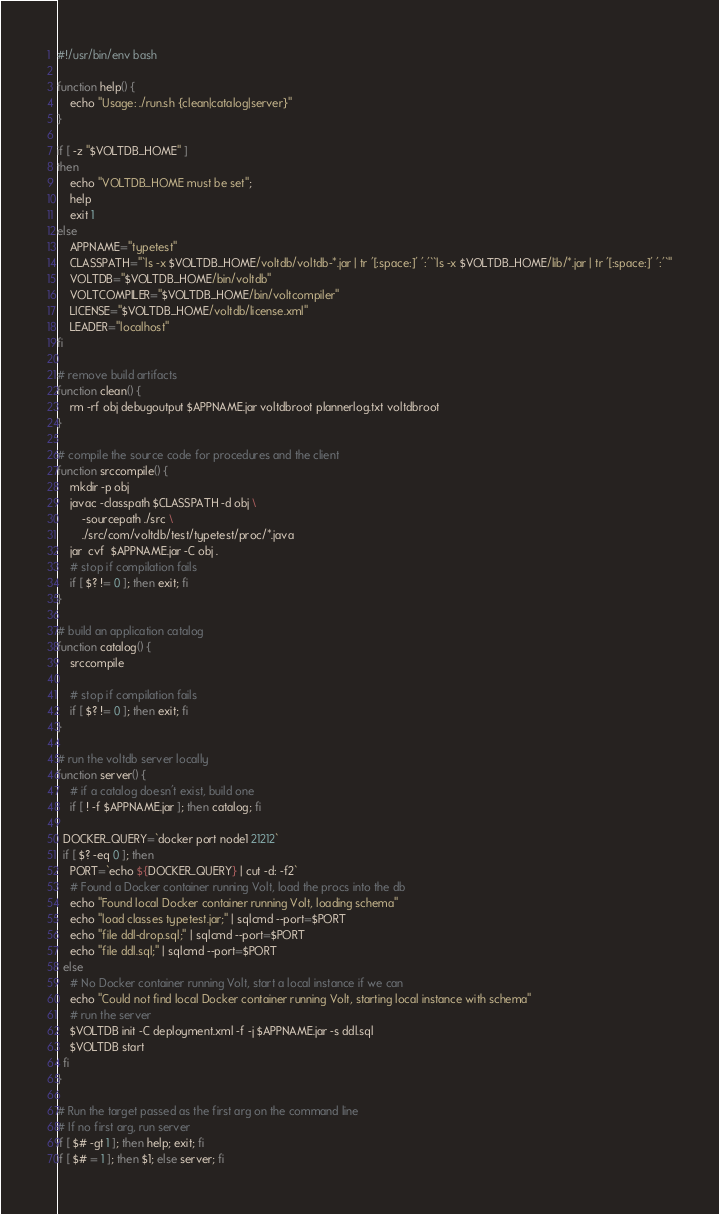<code> <loc_0><loc_0><loc_500><loc_500><_Bash_>#!/usr/bin/env bash

function help() {
    echo "Usage: ./run.sh {clean|catalog|server}"
}

if [ -z "$VOLTDB_HOME" ]
then
    echo "VOLTDB_HOME must be set";
    help
    exit 1
else
    APPNAME="typetest"
    CLASSPATH="`ls -x $VOLTDB_HOME/voltdb/voltdb-*.jar | tr '[:space:]' ':'``ls -x $VOLTDB_HOME/lib/*.jar | tr '[:space:]' ':'`"
    VOLTDB="$VOLTDB_HOME/bin/voltdb"
    VOLTCOMPILER="$VOLTDB_HOME/bin/voltcompiler"
    LICENSE="$VOLTDB_HOME/voltdb/license.xml"
    LEADER="localhost"
fi

# remove build artifacts
function clean() {
    rm -rf obj debugoutput $APPNAME.jar voltdbroot plannerlog.txt voltdbroot
}

# compile the source code for procedures and the client
function srccompile() {
    mkdir -p obj
    javac -classpath $CLASSPATH -d obj \
        -sourcepath ./src \
        ./src/com/voltdb/test/typetest/proc/*.java
    jar  cvf  $APPNAME.jar -C obj .
    # stop if compilation fails
    if [ $? != 0 ]; then exit; fi
}

# build an application catalog
function catalog() {
    srccompile

    # stop if compilation fails
    if [ $? != 0 ]; then exit; fi
}

# run the voltdb server locally
function server() {
    # if a catalog doesn't exist, build one
    if [ ! -f $APPNAME.jar ]; then catalog; fi
    
  DOCKER_QUERY=`docker port node1 21212`
  if [ $? -eq 0 ]; then
    PORT=`echo ${DOCKER_QUERY} | cut -d: -f2`
    # Found a Docker container running Volt, load the procs into the db
    echo "Found local Docker container running Volt, loading schema"
    echo "load classes typetest.jar;" | sqlcmd --port=$PORT
    echo "file ddl-drop.sql;" | sqlcmd --port=$PORT
    echo "file ddl.sql;" | sqlcmd --port=$PORT
  else
    # No Docker container running Volt, start a local instance if we can
    echo "Could not find local Docker container running Volt, starting local instance with schema"
    # run the server
    $VOLTDB init -C deployment.xml -f -j $APPNAME.jar -s ddl.sql
    $VOLTDB start
  fi
}

# Run the target passed as the first arg on the command line
# If no first arg, run server
if [ $# -gt 1 ]; then help; exit; fi
if [ $# = 1 ]; then $1; else server; fi</code> 